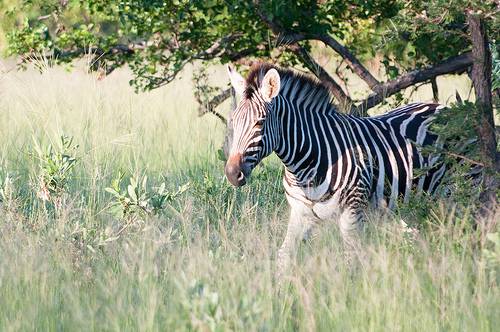Please provide the bounding box coordinate of the region this sentence describes: zebra has pointy ears. The bounding box coordinates for the region describing the zebra’s pointy ears are [0.41, 0.28, 0.58, 0.43]. This area likely captures the ears in addition to part of the head. 